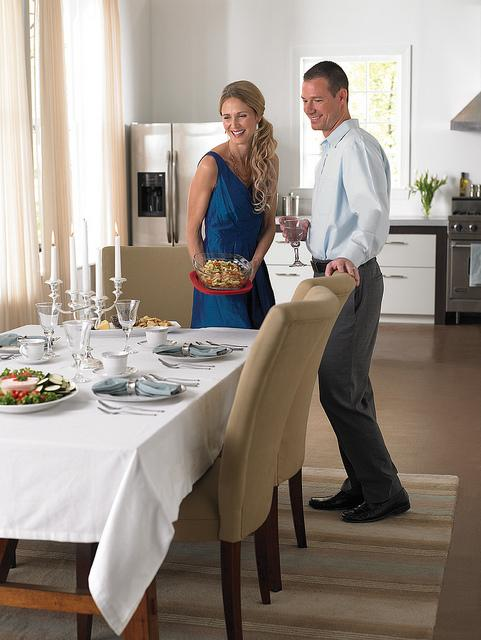What is the name of dining candles? candlesticks 